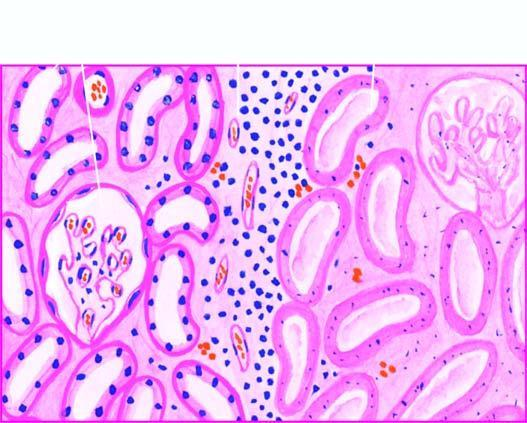how does the affected area on right show cells?
Answer the question using a single word or phrase. With intensely eosinophilic cytoplasm of tubular cells 